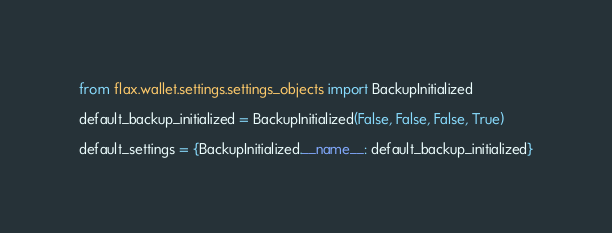<code> <loc_0><loc_0><loc_500><loc_500><_Python_>from flax.wallet.settings.settings_objects import BackupInitialized

default_backup_initialized = BackupInitialized(False, False, False, True)

default_settings = {BackupInitialized.__name__: default_backup_initialized}
</code> 